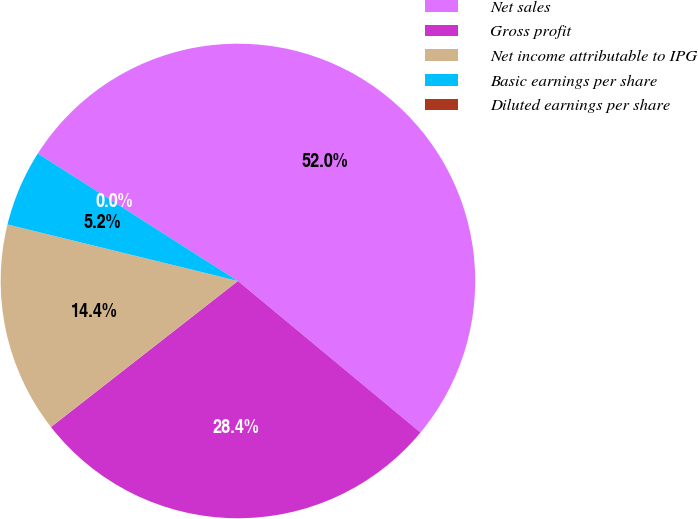Convert chart to OTSL. <chart><loc_0><loc_0><loc_500><loc_500><pie_chart><fcel>Net sales<fcel>Gross profit<fcel>Net income attributable to IPG<fcel>Basic earnings per share<fcel>Diluted earnings per share<nl><fcel>52.0%<fcel>28.42%<fcel>14.38%<fcel>5.2%<fcel>0.0%<nl></chart> 